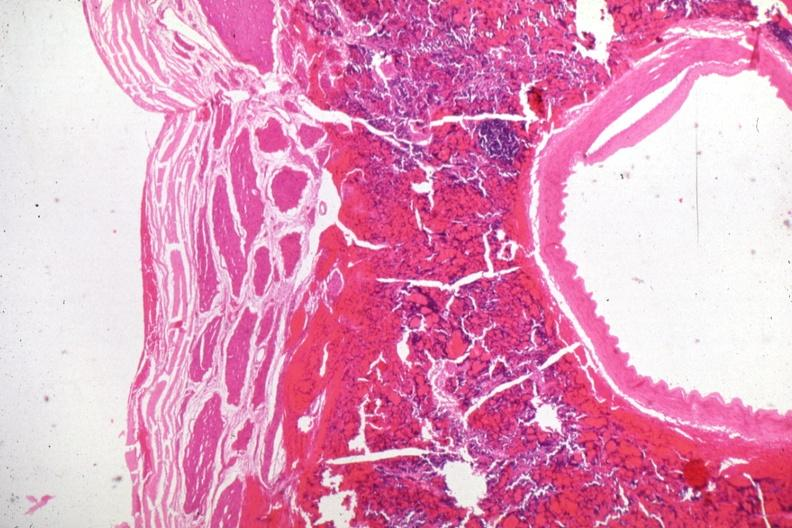what is present?
Answer the question using a single word or phrase. Malignant adenoma 